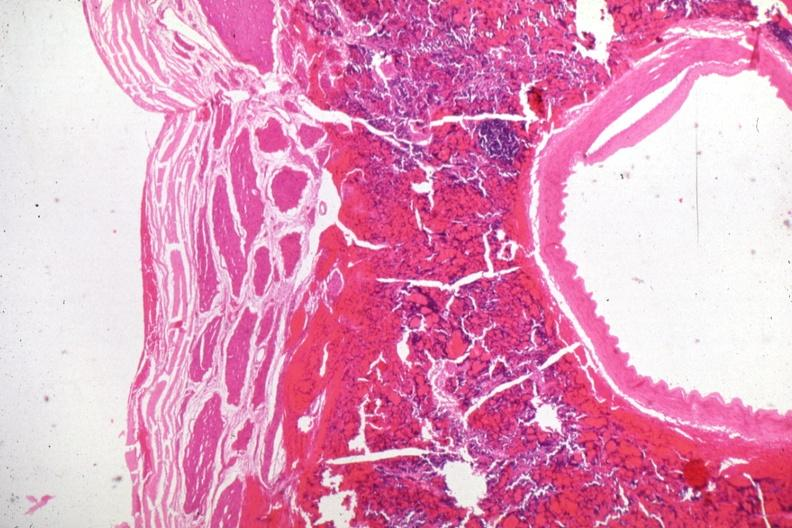what is present?
Answer the question using a single word or phrase. Malignant adenoma 